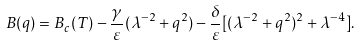Convert formula to latex. <formula><loc_0><loc_0><loc_500><loc_500>B ( q ) = B _ { c } ( T ) - \frac { \gamma } { \varepsilon } ( \lambda ^ { - 2 } + q ^ { 2 } ) - \frac { \delta } { \varepsilon } [ ( \lambda ^ { - 2 } + q ^ { 2 } ) ^ { 2 } + \lambda ^ { - 4 } ] .</formula> 